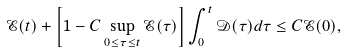<formula> <loc_0><loc_0><loc_500><loc_500>\mathcal { E } ( t ) + \left [ 1 - C \sup _ { 0 \leq \tau \leq t } \mathcal { E } ( \tau ) \right ] \int _ { 0 } ^ { t } \mathcal { D } ( \tau ) d \tau \leq C \mathcal { E } ( 0 ) ,</formula> 